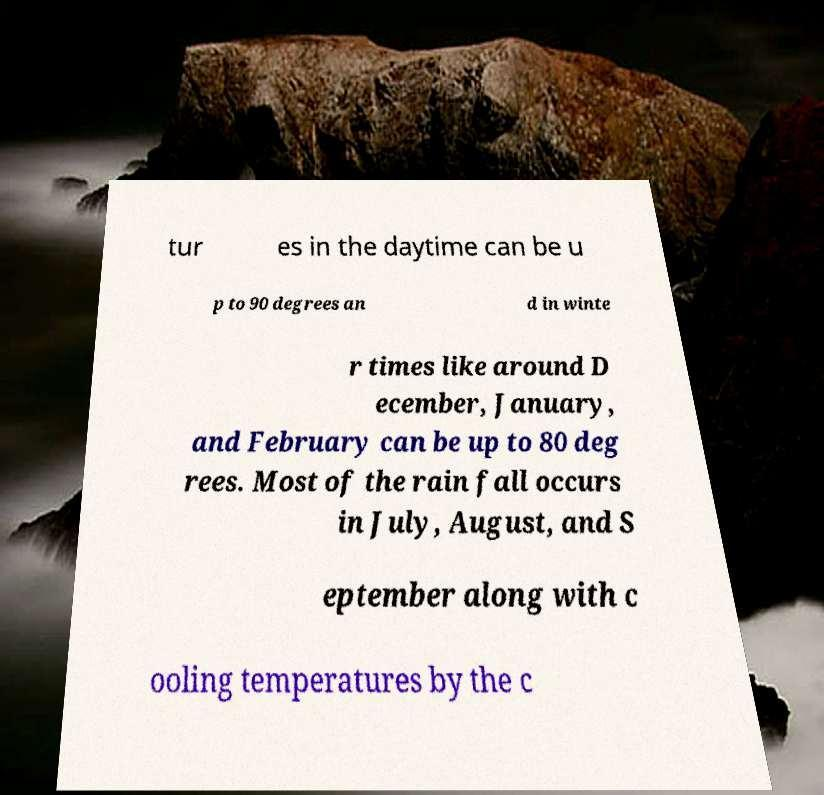Could you assist in decoding the text presented in this image and type it out clearly? tur es in the daytime can be u p to 90 degrees an d in winte r times like around D ecember, January, and February can be up to 80 deg rees. Most of the rain fall occurs in July, August, and S eptember along with c ooling temperatures by the c 